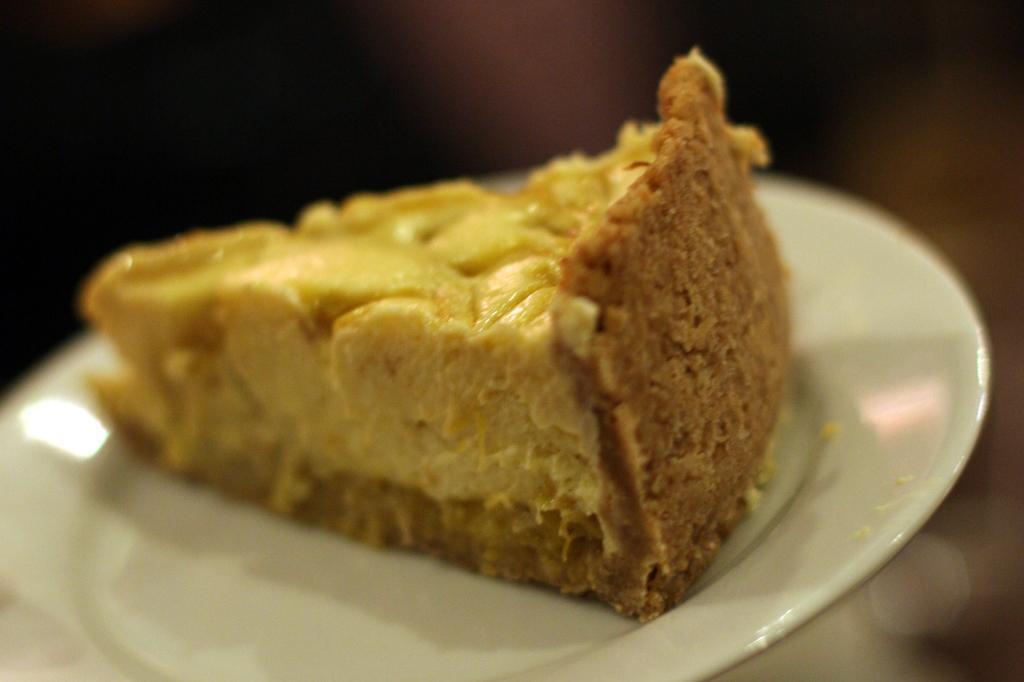How would you summarize this image in a sentence or two? On this white plate there is a piece of food. Background it is blur. 